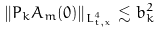Convert formula to latex. <formula><loc_0><loc_0><loc_500><loc_500>\| P _ { k } A _ { m } ( 0 ) \| _ { L _ { t , x } ^ { 4 } } \lesssim b _ { k } ^ { 2 }</formula> 